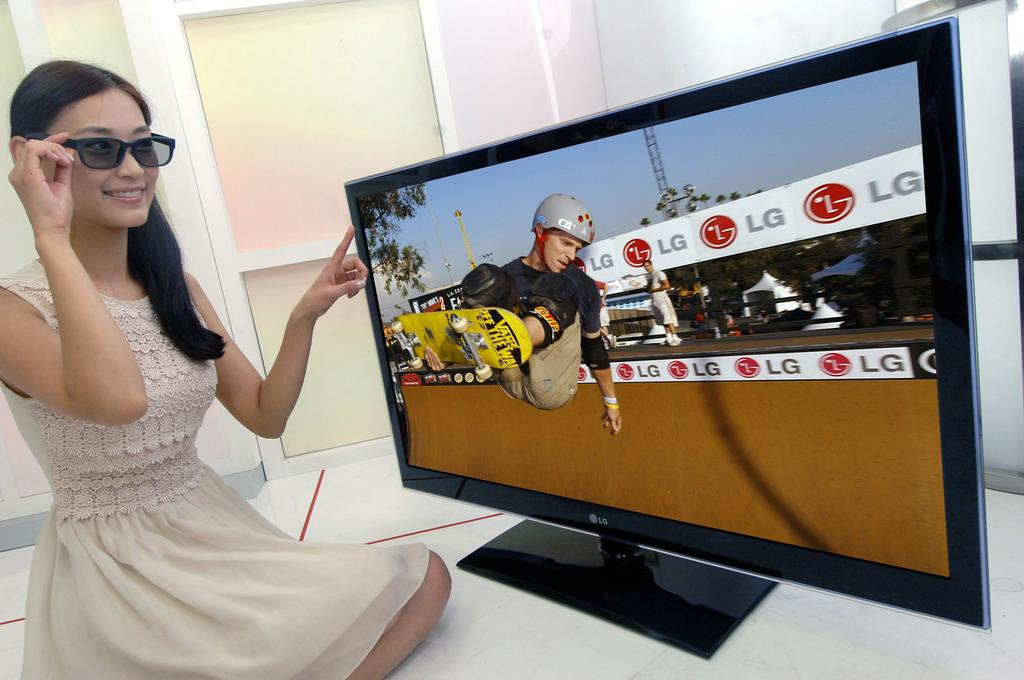<image>
Provide a brief description of the given image. A woman watches a television displaying a man skateboarding in a half-pipe with LG advertisements. 